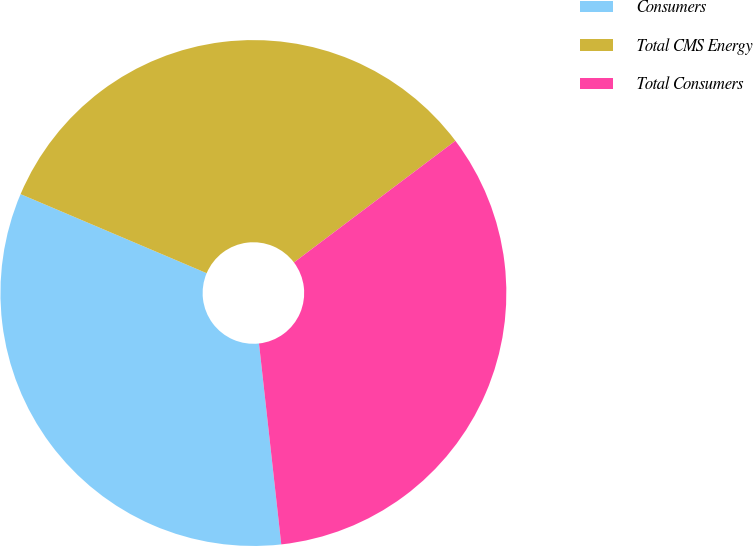<chart> <loc_0><loc_0><loc_500><loc_500><pie_chart><fcel>Consumers<fcel>Total CMS Energy<fcel>Total Consumers<nl><fcel>33.15%<fcel>33.33%<fcel>33.52%<nl></chart> 